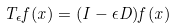<formula> <loc_0><loc_0><loc_500><loc_500>T _ { \epsilon } f ( x ) = ( I - \epsilon D ) f ( x )</formula> 